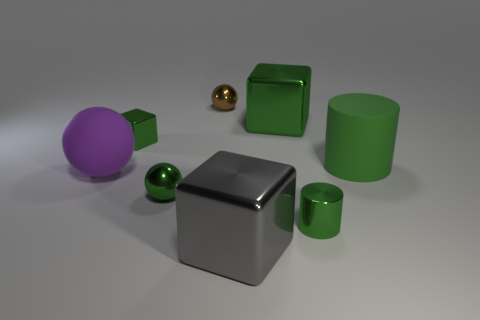Subtract all green cubes. How many were subtracted if there are1green cubes left? 1 Add 1 big cyan metal blocks. How many objects exist? 9 Subtract all spheres. How many objects are left? 5 Add 3 small green balls. How many small green balls are left? 4 Add 1 big blocks. How many big blocks exist? 3 Subtract 1 green balls. How many objects are left? 7 Subtract all green cubes. Subtract all small green shiny cylinders. How many objects are left? 5 